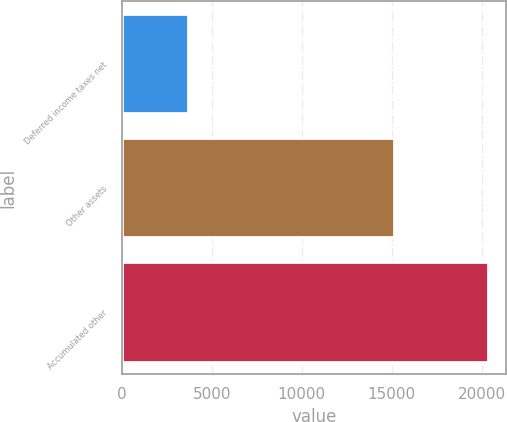<chart> <loc_0><loc_0><loc_500><loc_500><bar_chart><fcel>Deferred income taxes net<fcel>Other assets<fcel>Accumulated other<nl><fcel>3687<fcel>15116<fcel>20340<nl></chart> 